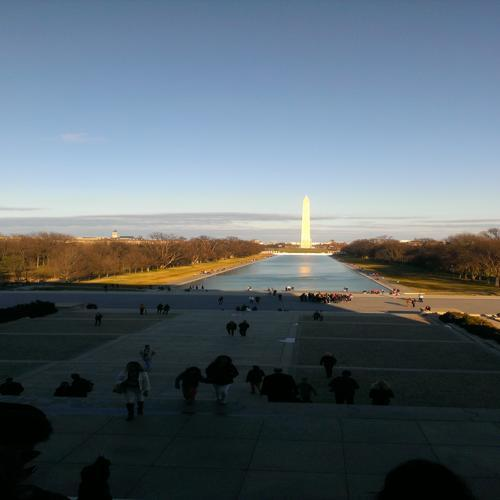What is the main issue in the structure of the figure?
A. horizontal stretching and distortion
B. clear structure
C. vertical compression
D. no issue
Answer with the option's letter from the given choices directly. The structure of the figure in the image does not exhibit any horizontal stretching and distortion, vertical compression, or other issues. The figure, which appears to be a well-known monument, is depicted with a clear and undistorted structure; thus the appropriate answer to the question would be D. no issue. 